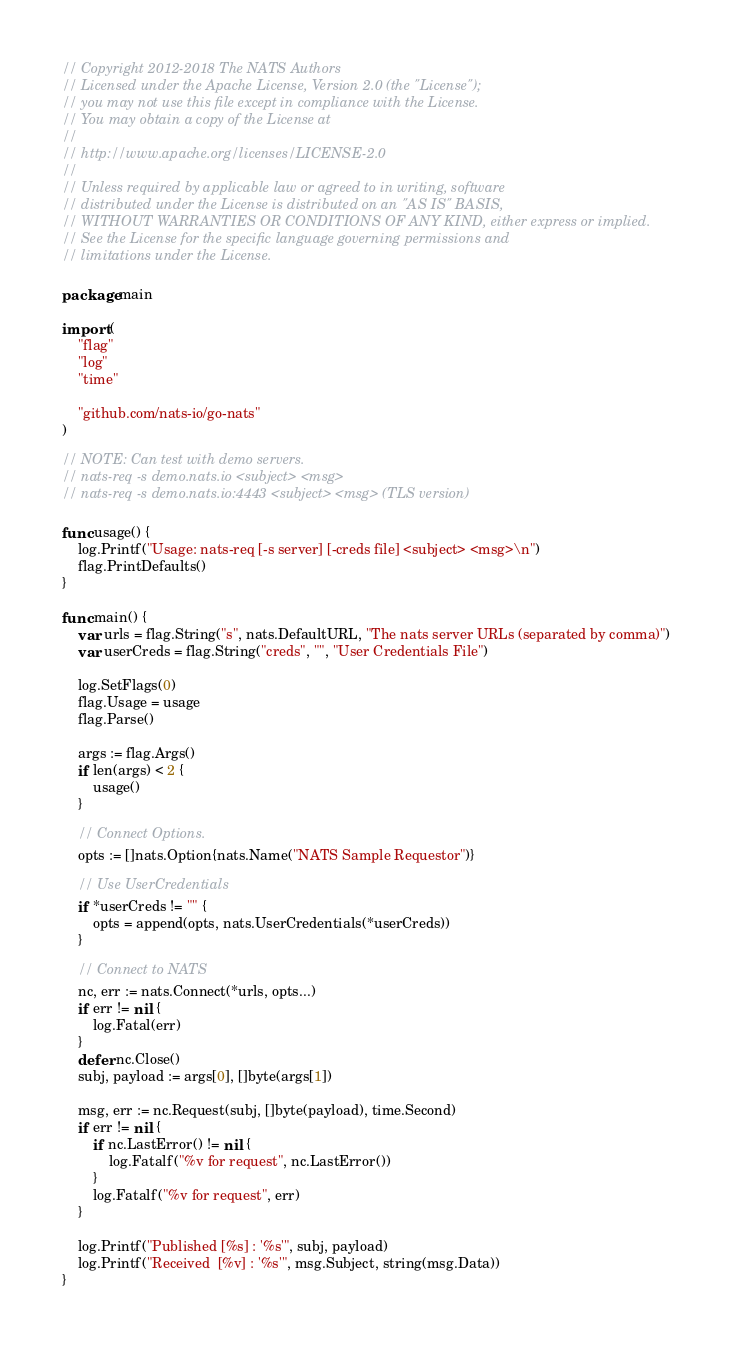Convert code to text. <code><loc_0><loc_0><loc_500><loc_500><_Go_>// Copyright 2012-2018 The NATS Authors
// Licensed under the Apache License, Version 2.0 (the "License");
// you may not use this file except in compliance with the License.
// You may obtain a copy of the License at
//
// http://www.apache.org/licenses/LICENSE-2.0
//
// Unless required by applicable law or agreed to in writing, software
// distributed under the License is distributed on an "AS IS" BASIS,
// WITHOUT WARRANTIES OR CONDITIONS OF ANY KIND, either express or implied.
// See the License for the specific language governing permissions and
// limitations under the License.

package main

import (
	"flag"
	"log"
	"time"

	"github.com/nats-io/go-nats"
)

// NOTE: Can test with demo servers.
// nats-req -s demo.nats.io <subject> <msg>
// nats-req -s demo.nats.io:4443 <subject> <msg> (TLS version)

func usage() {
	log.Printf("Usage: nats-req [-s server] [-creds file] <subject> <msg>\n")
	flag.PrintDefaults()
}

func main() {
	var urls = flag.String("s", nats.DefaultURL, "The nats server URLs (separated by comma)")
	var userCreds = flag.String("creds", "", "User Credentials File")

	log.SetFlags(0)
	flag.Usage = usage
	flag.Parse()

	args := flag.Args()
	if len(args) < 2 {
		usage()
	}

	// Connect Options.
	opts := []nats.Option{nats.Name("NATS Sample Requestor")}

	// Use UserCredentials
	if *userCreds != "" {
		opts = append(opts, nats.UserCredentials(*userCreds))
	}

	// Connect to NATS
	nc, err := nats.Connect(*urls, opts...)
	if err != nil {
		log.Fatal(err)
	}
	defer nc.Close()
	subj, payload := args[0], []byte(args[1])

	msg, err := nc.Request(subj, []byte(payload), time.Second)
	if err != nil {
		if nc.LastError() != nil {
			log.Fatalf("%v for request", nc.LastError())
		}
		log.Fatalf("%v for request", err)
	}

	log.Printf("Published [%s] : '%s'", subj, payload)
	log.Printf("Received  [%v] : '%s'", msg.Subject, string(msg.Data))
}
</code> 